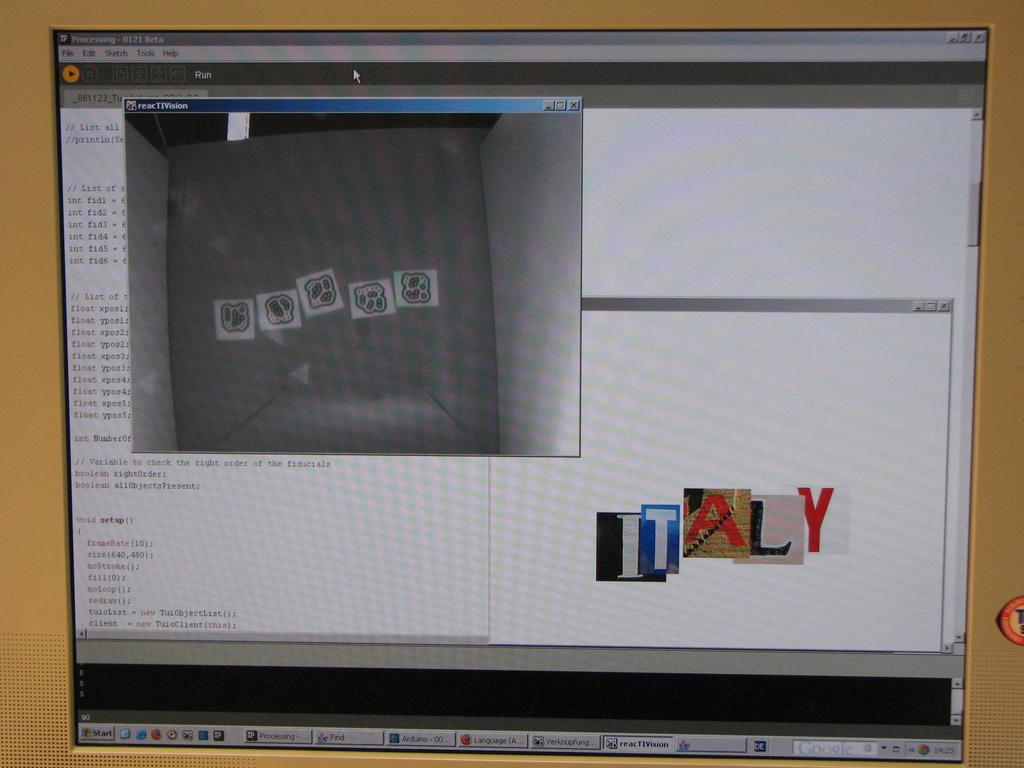<image>
Present a compact description of the photo's key features. Screen showing some editing and the words "ITALY" on it. 